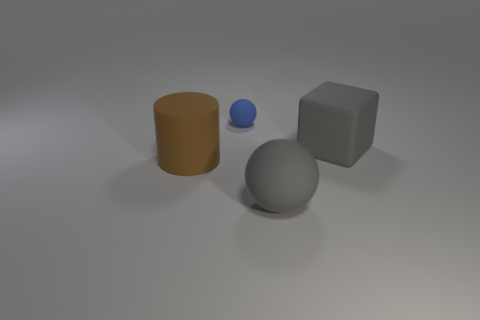Is the material of the gray block the same as the sphere that is in front of the large brown rubber thing?
Your answer should be very brief. Yes. There is a gray object that is on the left side of the big gray matte cube; is it the same shape as the small blue thing?
Offer a terse response. Yes. There is a tiny rubber object; is it the same shape as the matte object in front of the brown rubber cylinder?
Provide a short and direct response. Yes. There is a thing that is both behind the rubber cylinder and on the right side of the small blue matte ball; what color is it?
Ensure brevity in your answer.  Gray. Is there a big rubber object?
Your response must be concise. Yes. Is the number of big cubes that are in front of the big cylinder the same as the number of big yellow cylinders?
Your response must be concise. Yes. How many other objects are the same shape as the blue object?
Ensure brevity in your answer.  1. What shape is the tiny blue thing?
Keep it short and to the point. Sphere. Does the gray ball have the same material as the large brown thing?
Your response must be concise. Yes. Is the number of things on the left side of the gray rubber sphere the same as the number of rubber things that are behind the gray matte block?
Provide a succinct answer. No. 